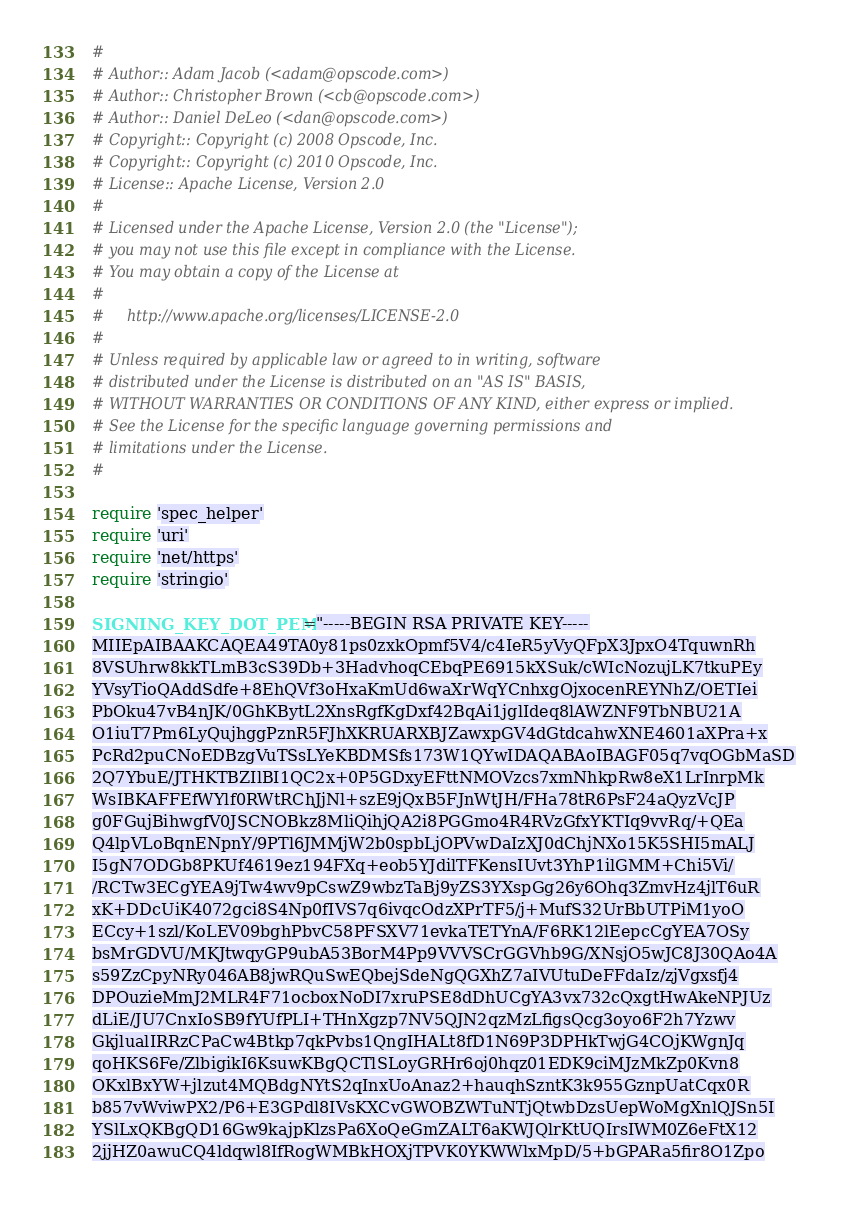<code> <loc_0><loc_0><loc_500><loc_500><_Ruby_>#
# Author:: Adam Jacob (<adam@opscode.com>)
# Author:: Christopher Brown (<cb@opscode.com>)
# Author:: Daniel DeLeo (<dan@opscode.com>)
# Copyright:: Copyright (c) 2008 Opscode, Inc.
# Copyright:: Copyright (c) 2010 Opscode, Inc.
# License:: Apache License, Version 2.0
#
# Licensed under the Apache License, Version 2.0 (the "License");
# you may not use this file except in compliance with the License.
# You may obtain a copy of the License at
#
#     http://www.apache.org/licenses/LICENSE-2.0
#
# Unless required by applicable law or agreed to in writing, software
# distributed under the License is distributed on an "AS IS" BASIS,
# WITHOUT WARRANTIES OR CONDITIONS OF ANY KIND, either express or implied.
# See the License for the specific language governing permissions and
# limitations under the License.
#

require 'spec_helper'
require 'uri'
require 'net/https'
require 'stringio'

SIGNING_KEY_DOT_PEM="-----BEGIN RSA PRIVATE KEY-----
MIIEpAIBAAKCAQEA49TA0y81ps0zxkOpmf5V4/c4IeR5yVyQFpX3JpxO4TquwnRh
8VSUhrw8kkTLmB3cS39Db+3HadvhoqCEbqPE6915kXSuk/cWIcNozujLK7tkuPEy
YVsyTioQAddSdfe+8EhQVf3oHxaKmUd6waXrWqYCnhxgOjxocenREYNhZ/OETIei
PbOku47vB4nJK/0GhKBytL2XnsRgfKgDxf42BqAi1jglIdeq8lAWZNF9TbNBU21A
O1iuT7Pm6LyQujhggPznR5FJhXKRUARXBJZawxpGV4dGtdcahwXNE4601aXPra+x
PcRd2puCNoEDBzgVuTSsLYeKBDMSfs173W1QYwIDAQABAoIBAGF05q7vqOGbMaSD
2Q7YbuE/JTHKTBZIlBI1QC2x+0P5GDxyEFttNMOVzcs7xmNhkpRw8eX1LrInrpMk
WsIBKAFFEfWYlf0RWtRChJjNl+szE9jQxB5FJnWtJH/FHa78tR6PsF24aQyzVcJP
g0FGujBihwgfV0JSCNOBkz8MliQihjQA2i8PGGmo4R4RVzGfxYKTIq9vvRq/+QEa
Q4lpVLoBqnENpnY/9PTl6JMMjW2b0spbLjOPVwDaIzXJ0dChjNXo15K5SHI5mALJ
I5gN7ODGb8PKUf4619ez194FXq+eob5YJdilTFKensIUvt3YhP1ilGMM+Chi5Vi/
/RCTw3ECgYEA9jTw4wv9pCswZ9wbzTaBj9yZS3YXspGg26y6Ohq3ZmvHz4jlT6uR
xK+DDcUiK4072gci8S4Np0fIVS7q6ivqcOdzXPrTF5/j+MufS32UrBbUTPiM1yoO
ECcy+1szl/KoLEV09bghPbvC58PFSXV71evkaTETYnA/F6RK12lEepcCgYEA7OSy
bsMrGDVU/MKJtwqyGP9ubA53BorM4Pp9VVVSCrGGVhb9G/XNsjO5wJC8J30QAo4A
s59ZzCpyNRy046AB8jwRQuSwEQbejSdeNgQGXhZ7aIVUtuDeFFdaIz/zjVgxsfj4
DPOuzieMmJ2MLR4F71ocboxNoDI7xruPSE8dDhUCgYA3vx732cQxgtHwAkeNPJUz
dLiE/JU7CnxIoSB9fYUfPLI+THnXgzp7NV5QJN2qzMzLfigsQcg3oyo6F2h7Yzwv
GkjlualIRRzCPaCw4Btkp7qkPvbs1QngIHALt8fD1N69P3DPHkTwjG4COjKWgnJq
qoHKS6Fe/ZlbigikI6KsuwKBgQCTlSLoyGRHr6oj0hqz01EDK9ciMJzMkZp0Kvn8
OKxlBxYW+jlzut4MQBdgNYtS2qInxUoAnaz2+hauqhSzntK3k955GznpUatCqx0R
b857vWviwPX2/P6+E3GPdl8IVsKXCvGWOBZWTuNTjQtwbDzsUepWoMgXnlQJSn5I
YSlLxQKBgQD16Gw9kajpKlzsPa6XoQeGmZALT6aKWJQlrKtUQIrsIWM0Z6eFtX12
2jjHZ0awuCQ4ldqwl8IfRogWMBkHOXjTPVK0YKWWlxMpD/5+bGPARa5fir8O1Zpo</code> 